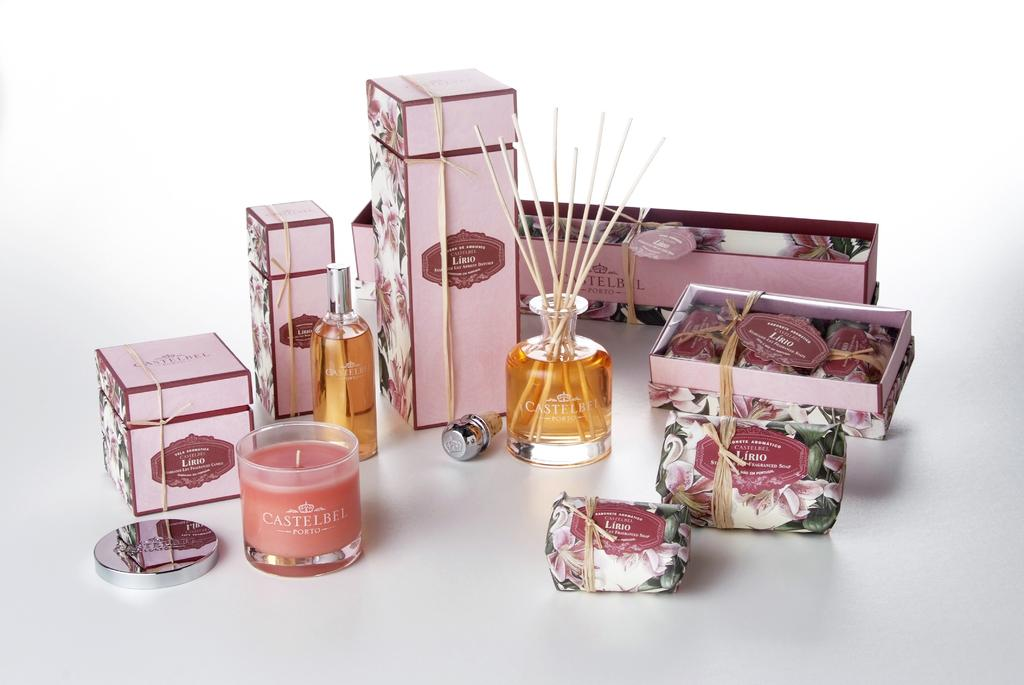<image>
Provide a brief description of the given image. A product display layout for Castelbel Porto products showing candles,diffusers, and sprays 